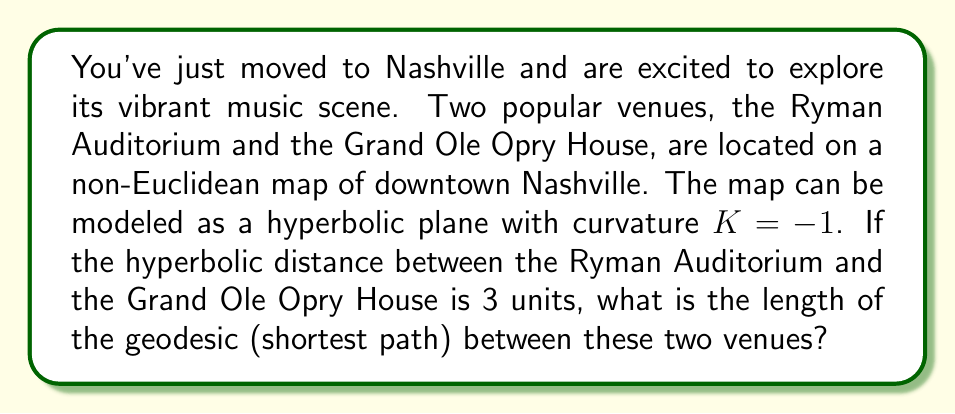Show me your answer to this math problem. Let's approach this step-by-step:

1) In hyperbolic geometry, the shortest path between two points is a geodesic. On a hyperbolic plane with curvature $K = -1$, the length of a geodesic $L$ is related to the hyperbolic distance $d$ by the formula:

   $$L = 2 \sinh^{-1}\left(\frac{d}{2}\right)$$

2) We are given that the hyperbolic distance $d$ between the Ryman Auditorium and the Grand Ole Opry House is 3 units.

3) Let's substitute this into our formula:

   $$L = 2 \sinh^{-1}\left(\frac{3}{2}\right)$$

4) To calculate this, we need to evaluate $\sinh^{-1}\left(\frac{3}{2}\right)$:

   $$\sinh^{-1}\left(\frac{3}{2}\right) = \ln\left(\frac{3}{2} + \sqrt{\left(\frac{3}{2}\right)^2 + 1}\right)$$

5) Simplifying inside the square root:

   $$\sinh^{-1}\left(\frac{3}{2}\right) = \ln\left(\frac{3}{2} + \sqrt{\frac{9}{4} + 1}\right) = \ln\left(\frac{3}{2} + \sqrt{\frac{13}{4}}\right)$$

6) Simplifying further:

   $$\sinh^{-1}\left(\frac{3}{2}\right) = \ln\left(\frac{3 + \sqrt{13}}{2}\right)$$

7) Therefore, the length of the geodesic is:

   $$L = 2 \ln\left(\frac{3 + \sqrt{13}}{2}\right)$$

This is the exact length of the shortest path between the Ryman Auditorium and the Grand Ole Opry House on this hyperbolic map of Nashville.
Answer: $2 \ln\left(\frac{3 + \sqrt{13}}{2}\right)$ units 